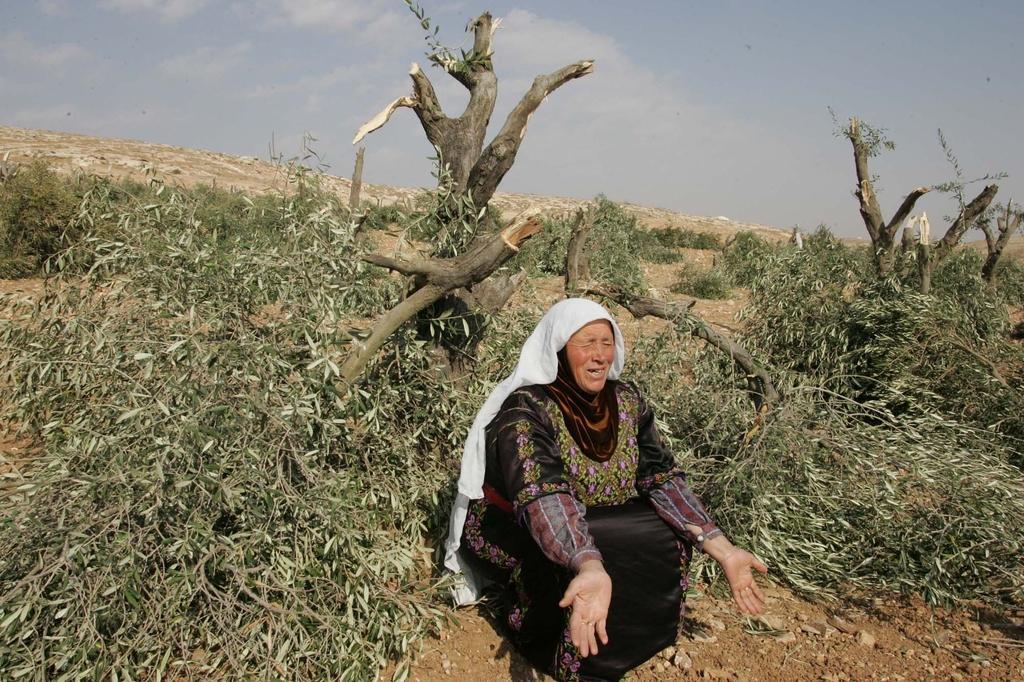In one or two sentences, can you explain what this image depicts? In the picture we can see a woman sitting on her legs and giving some expression and she is wearing a black color dress with some designs on it and behind her we can see some broken trees and in the background we can see a rock surface and sky. 